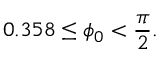Convert formula to latex. <formula><loc_0><loc_0><loc_500><loc_500>0 . 3 5 8 \leq \phi _ { 0 } < \frac { \pi } { 2 } .</formula> 